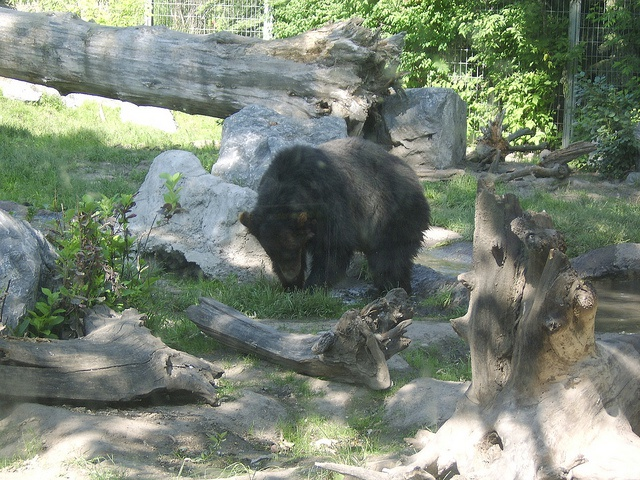Describe the objects in this image and their specific colors. I can see a bear in gray, black, and purple tones in this image. 